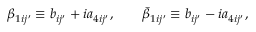<formula> <loc_0><loc_0><loc_500><loc_500>\beta _ { 1 i j ^ { \prime } } \equiv b _ { i j ^ { \prime } } + i a _ { 4 i j ^ { \prime } } , \quad \bar { \beta } _ { 1 i j ^ { \prime } } \equiv b _ { i j ^ { \prime } } - i a _ { 4 i j ^ { \prime } } ,</formula> 